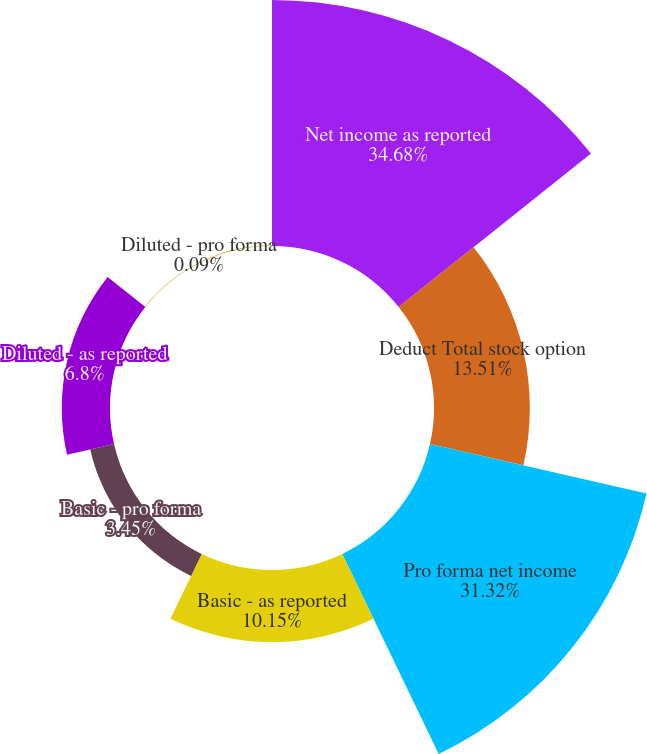Convert chart. <chart><loc_0><loc_0><loc_500><loc_500><pie_chart><fcel>Net income as reported<fcel>Deduct Total stock option<fcel>Pro forma net income<fcel>Basic - as reported<fcel>Basic - pro forma<fcel>Diluted - as reported<fcel>Diluted - pro forma<nl><fcel>34.68%<fcel>13.51%<fcel>31.32%<fcel>10.15%<fcel>3.45%<fcel>6.8%<fcel>0.09%<nl></chart> 